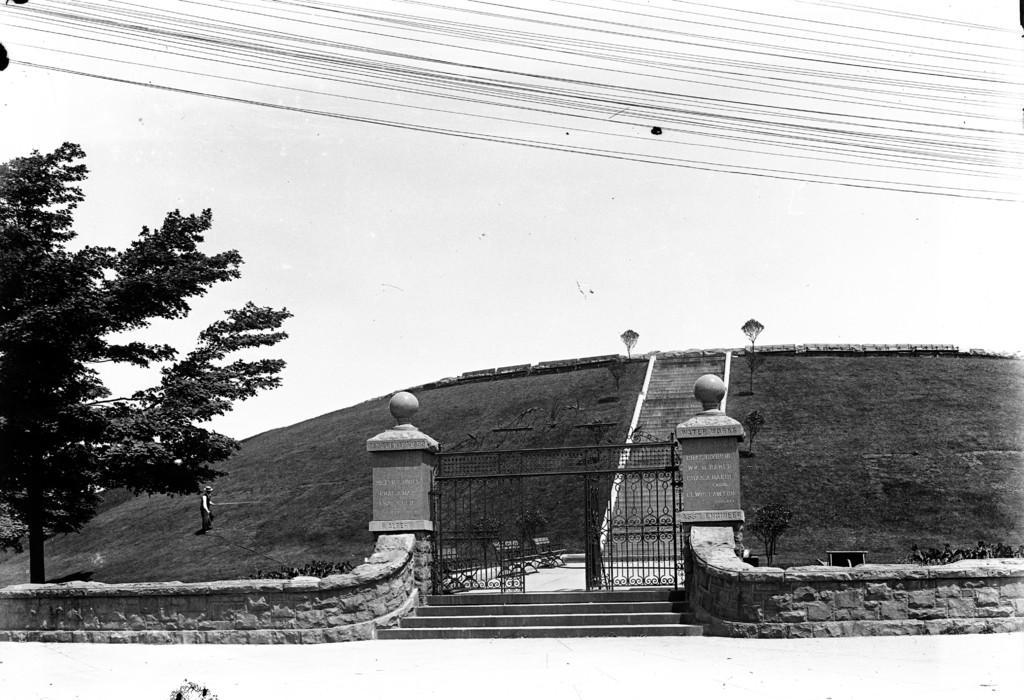Can you describe this image briefly? This image is a black and white image. This image is taken outdoors. At the top of the image there is a sky and there are many wires. On the left side of the image there is a tree and a man is walking on the ground. In the middle of the image there is a ground with grass on it and there are a few stairs. There are two lamps. At the bottom of the image there are two walls and there are two gates. There are a few stairs. 